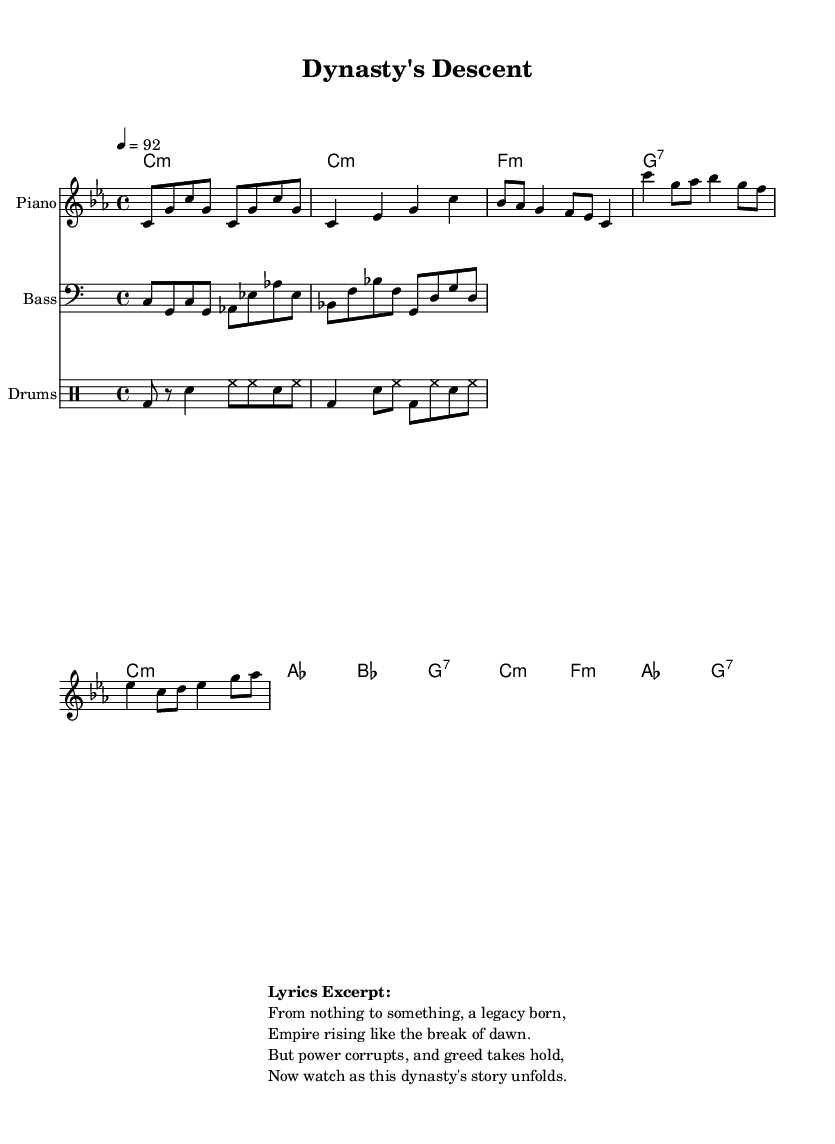What is the key signature of this music? The key signature is C minor, which is indicated by the presence of three flats in the key signature.
Answer: C minor What is the time signature of this piece? The time signature shown in the music is 4/4, which indicates that there are four beats per measure and the quarter note receives one beat.
Answer: 4/4 What is the tempo of the music? The tempo indicated in the score is 92, which is measured in beats per minute, suggesting a moderate pace for the hip hop piece.
Answer: 92 How many measures are in the verse section? The verse section contains four measures, as seen by the counting of the bars in that specific part of the score.
Answer: Four What instruments are used in this composition? The score includes Piano, Bass, and Drums as the three distinct instruments indicated in their respective staves.
Answer: Piano, Bass, Drums What narrative theme is suggested by the lyrics excerpt? The lyrics highlight themes of rising from nothing to creating a legacy, followed by the downfall due to greed and corruption, suggesting a dramatic family saga.
Answer: Legacy and downfall 